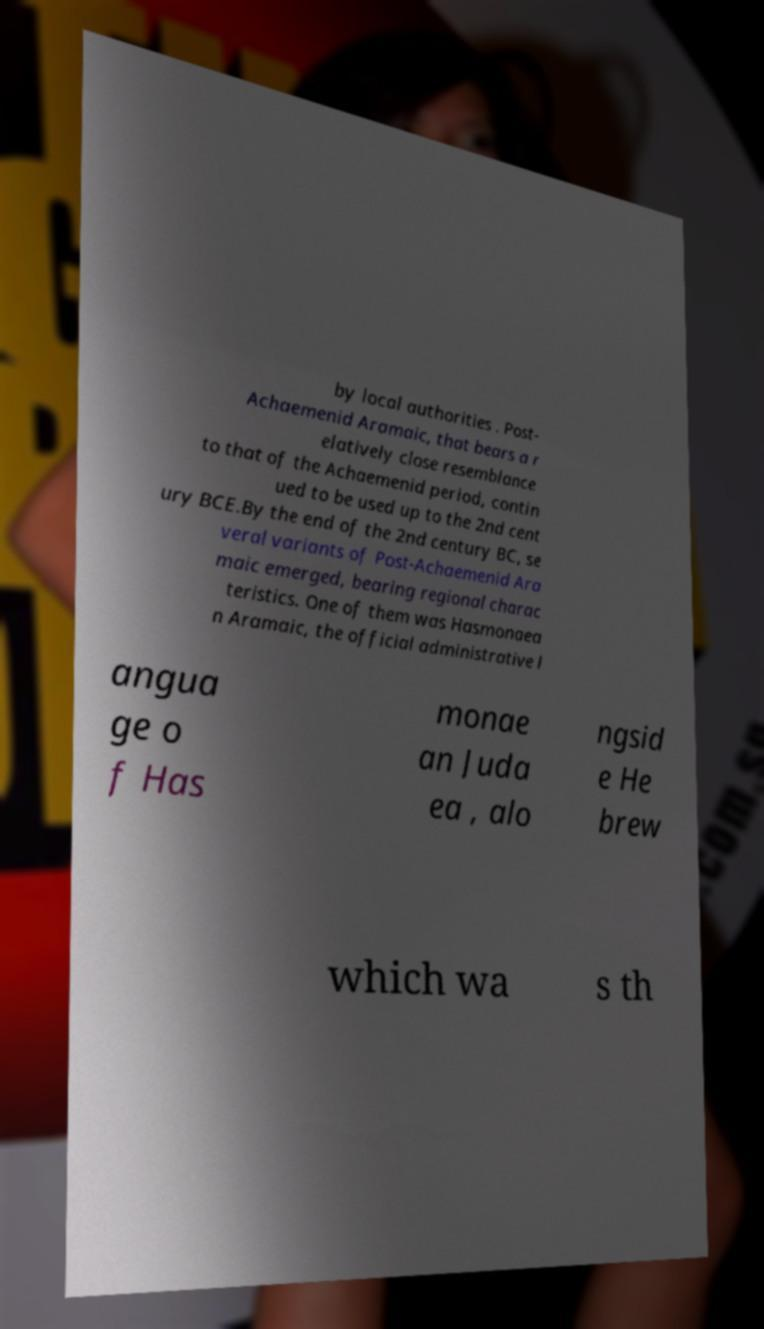Could you assist in decoding the text presented in this image and type it out clearly? by local authorities . Post- Achaemenid Aramaic, that bears a r elatively close resemblance to that of the Achaemenid period, contin ued to be used up to the 2nd cent ury BCE.By the end of the 2nd century BC, se veral variants of Post-Achaemenid Ara maic emerged, bearing regional charac teristics. One of them was Hasmonaea n Aramaic, the official administrative l angua ge o f Has monae an Juda ea , alo ngsid e He brew which wa s th 